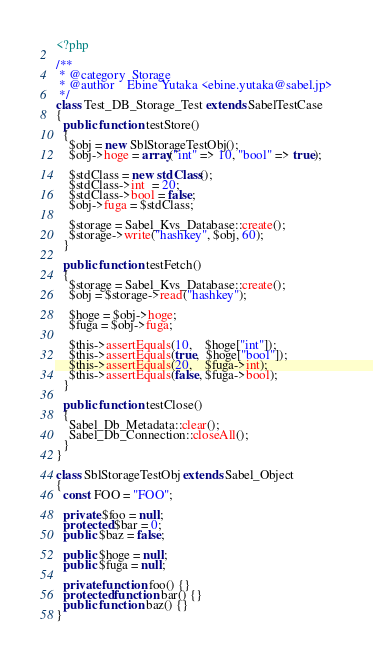<code> <loc_0><loc_0><loc_500><loc_500><_PHP_><?php

/**
 * @category  Storage
 * @author    Ebine Yutaka <ebine.yutaka@sabel.jp>
 */
class Test_DB_Storage_Test extends SabelTestCase
{
  public function testStore()
  {
    $obj = new SblStorageTestObj();
    $obj->hoge = array("int" => 10, "bool" => true);
    
    $stdClass = new stdClass();
    $stdClass->int  = 20;
    $stdClass->bool = false;
    $obj->fuga = $stdClass;
    
    $storage = Sabel_Kvs_Database::create();
    $storage->write("hashkey", $obj, 60);
  }
  
  public function testFetch()
  {
    $storage = Sabel_Kvs_Database::create();
    $obj = $storage->read("hashkey");
    
    $hoge = $obj->hoge;
    $fuga = $obj->fuga;
    
    $this->assertEquals(10,    $hoge["int"]);
    $this->assertEquals(true,  $hoge["bool"]);
    $this->assertEquals(20,    $fuga->int);
    $this->assertEquals(false, $fuga->bool);
  }
  
  public function testClose()
  {
    Sabel_Db_Metadata::clear();
    Sabel_Db_Connection::closeAll();
  }
}

class SblStorageTestObj extends Sabel_Object
{
  const FOO = "FOO";
  
  private $foo = null;
  protected $bar = 0;
  public $baz = false;
  
  public $hoge = null;
  public $fuga = null;
  
  private function foo() {}
  protected function bar() {}
  public function baz() {}
}
</code> 